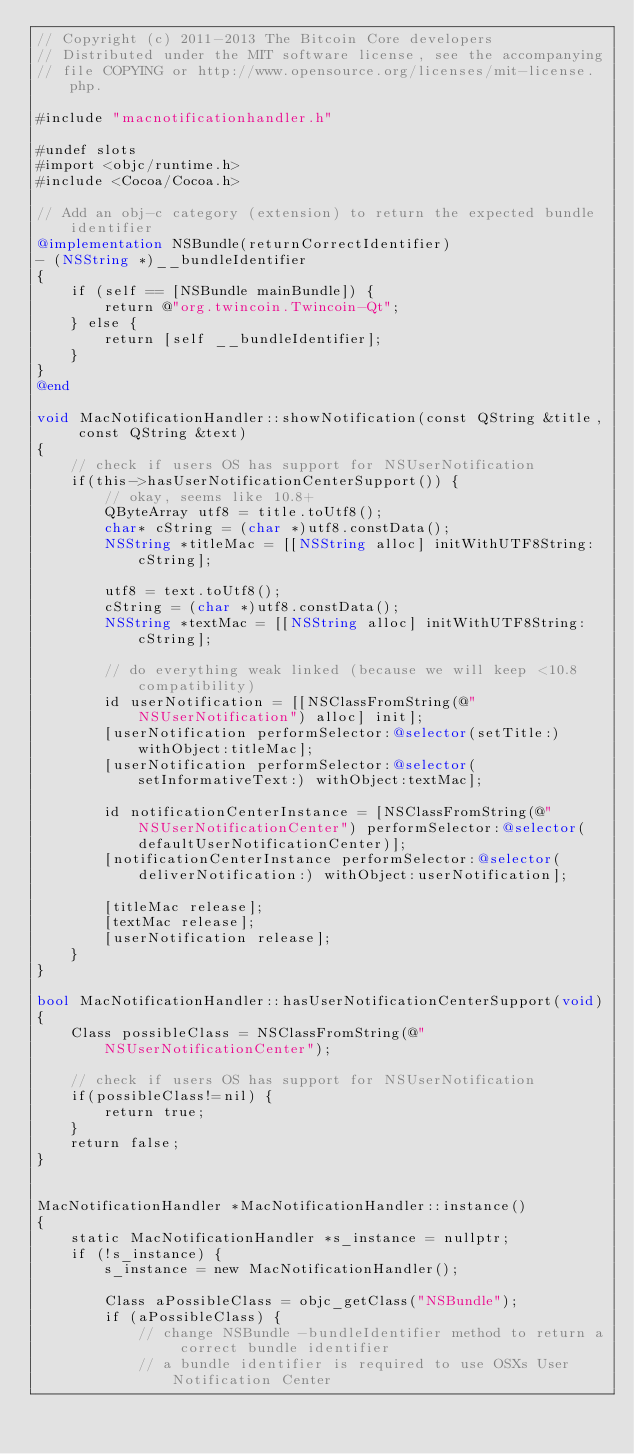Convert code to text. <code><loc_0><loc_0><loc_500><loc_500><_ObjectiveC_>// Copyright (c) 2011-2013 The Bitcoin Core developers
// Distributed under the MIT software license, see the accompanying
// file COPYING or http://www.opensource.org/licenses/mit-license.php.

#include "macnotificationhandler.h"

#undef slots
#import <objc/runtime.h>
#include <Cocoa/Cocoa.h>

// Add an obj-c category (extension) to return the expected bundle identifier
@implementation NSBundle(returnCorrectIdentifier)
- (NSString *)__bundleIdentifier
{
    if (self == [NSBundle mainBundle]) {
        return @"org.twincoin.Twincoin-Qt";
    } else {
        return [self __bundleIdentifier];
    }
}
@end

void MacNotificationHandler::showNotification(const QString &title, const QString &text)
{
    // check if users OS has support for NSUserNotification
    if(this->hasUserNotificationCenterSupport()) {
        // okay, seems like 10.8+
        QByteArray utf8 = title.toUtf8();
        char* cString = (char *)utf8.constData();
        NSString *titleMac = [[NSString alloc] initWithUTF8String:cString];

        utf8 = text.toUtf8();
        cString = (char *)utf8.constData();
        NSString *textMac = [[NSString alloc] initWithUTF8String:cString];

        // do everything weak linked (because we will keep <10.8 compatibility)
        id userNotification = [[NSClassFromString(@"NSUserNotification") alloc] init];
        [userNotification performSelector:@selector(setTitle:) withObject:titleMac];
        [userNotification performSelector:@selector(setInformativeText:) withObject:textMac];

        id notificationCenterInstance = [NSClassFromString(@"NSUserNotificationCenter") performSelector:@selector(defaultUserNotificationCenter)];
        [notificationCenterInstance performSelector:@selector(deliverNotification:) withObject:userNotification];

        [titleMac release];
        [textMac release];
        [userNotification release];
    }
}

bool MacNotificationHandler::hasUserNotificationCenterSupport(void)
{
    Class possibleClass = NSClassFromString(@"NSUserNotificationCenter");

    // check if users OS has support for NSUserNotification
    if(possibleClass!=nil) {
        return true;
    }
    return false;
}


MacNotificationHandler *MacNotificationHandler::instance()
{
    static MacNotificationHandler *s_instance = nullptr;
    if (!s_instance) {
        s_instance = new MacNotificationHandler();

        Class aPossibleClass = objc_getClass("NSBundle");
        if (aPossibleClass) {
            // change NSBundle -bundleIdentifier method to return a correct bundle identifier
            // a bundle identifier is required to use OSXs User Notification Center</code> 